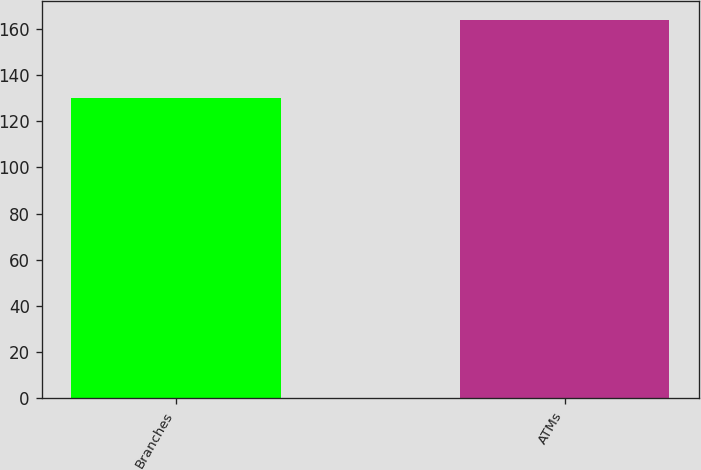Convert chart to OTSL. <chart><loc_0><loc_0><loc_500><loc_500><bar_chart><fcel>Branches<fcel>ATMs<nl><fcel>130<fcel>164<nl></chart> 